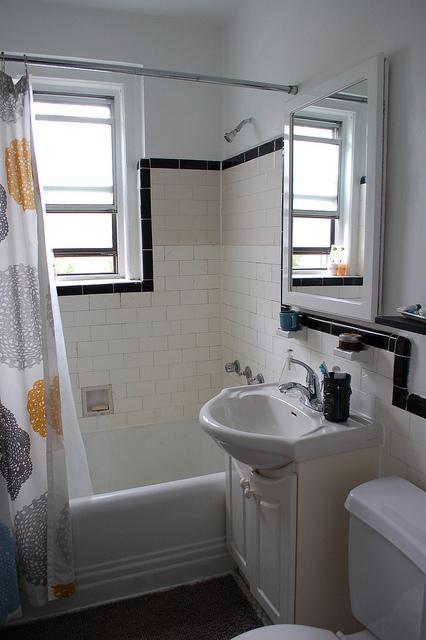What is one of the colors on the curtain?
Indicate the correct response by choosing from the four available options to answer the question.
Options: Red, purple, yellow, blue. Yellow. 